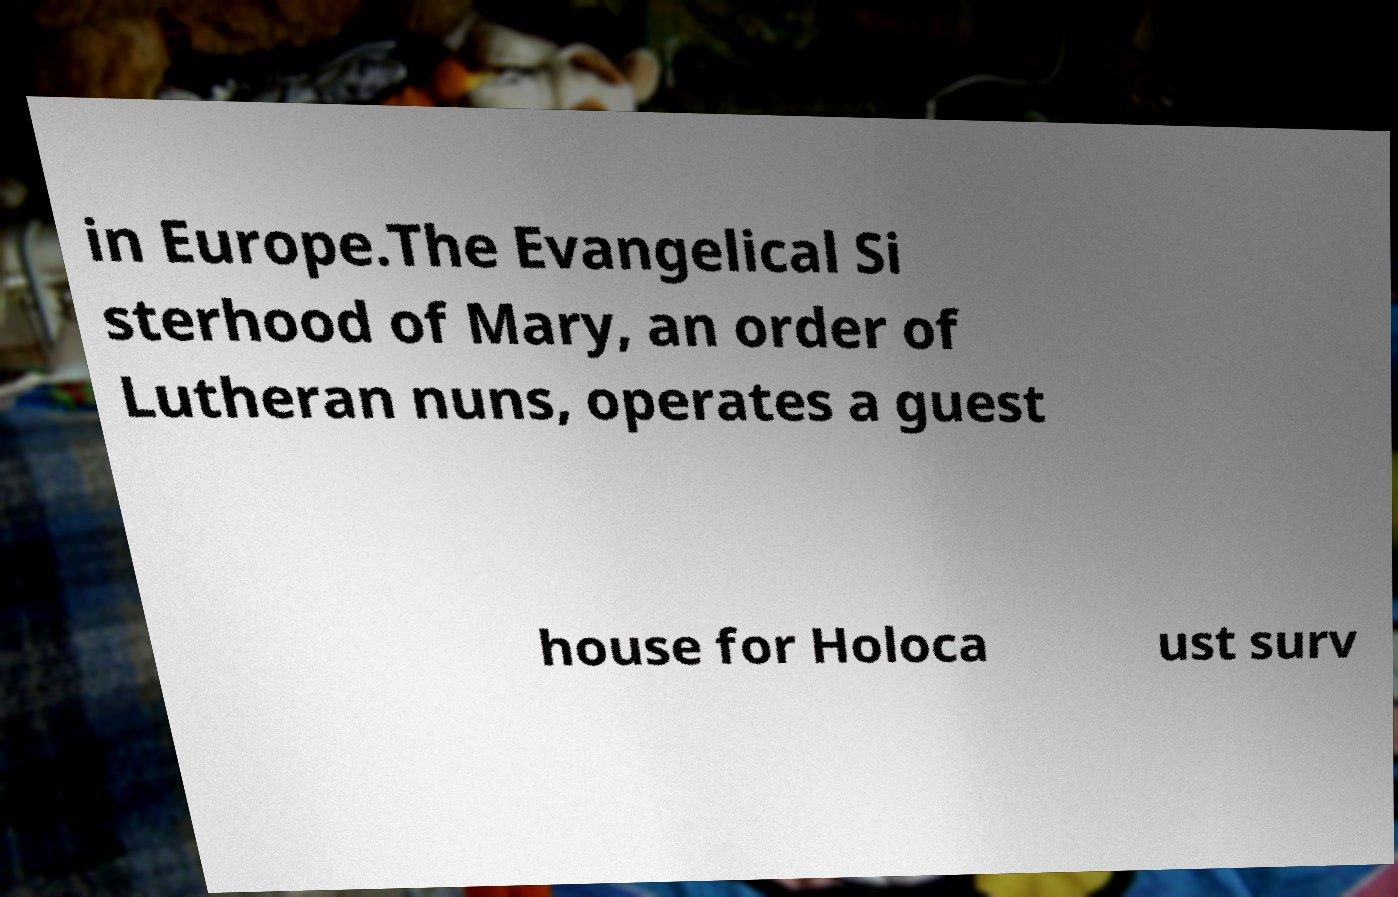Please identify and transcribe the text found in this image. in Europe.The Evangelical Si sterhood of Mary, an order of Lutheran nuns, operates a guest house for Holoca ust surv 